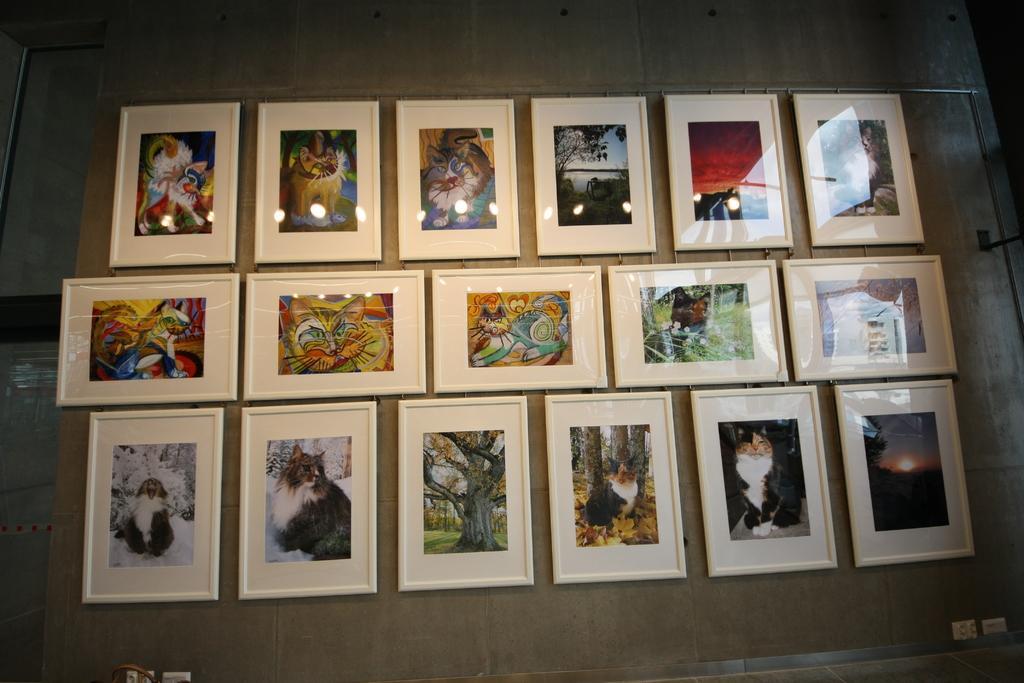Could you give a brief overview of what you see in this image? This image consists of many photo frames fixed on the wall. On the left, we can see a wall. 